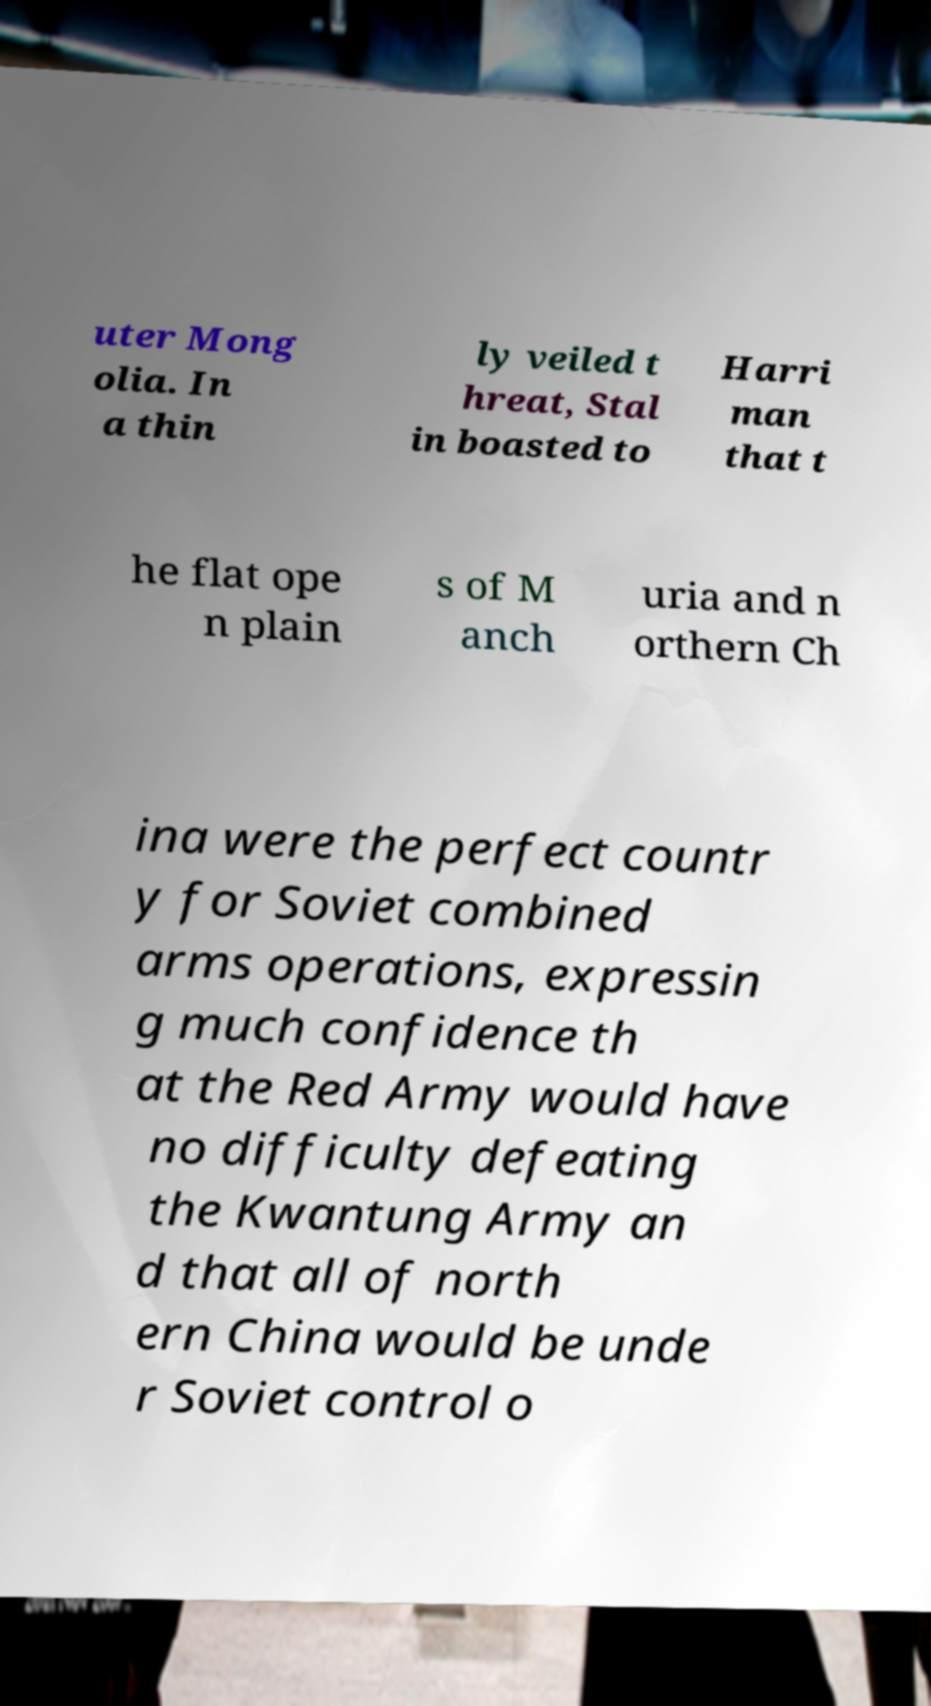Could you extract and type out the text from this image? uter Mong olia. In a thin ly veiled t hreat, Stal in boasted to Harri man that t he flat ope n plain s of M anch uria and n orthern Ch ina were the perfect countr y for Soviet combined arms operations, expressin g much confidence th at the Red Army would have no difficulty defeating the Kwantung Army an d that all of north ern China would be unde r Soviet control o 